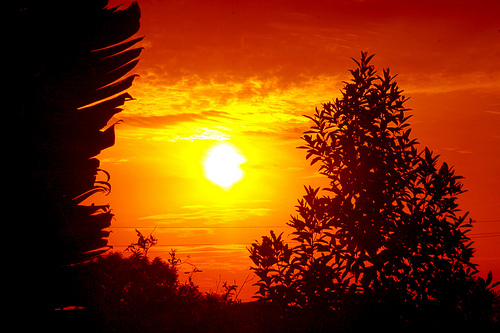<image>
Can you confirm if the sky is to the right of the tree? No. The sky is not to the right of the tree. The horizontal positioning shows a different relationship. 